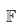Convert formula to latex. <formula><loc_0><loc_0><loc_500><loc_500>\mathbb { F }</formula> 